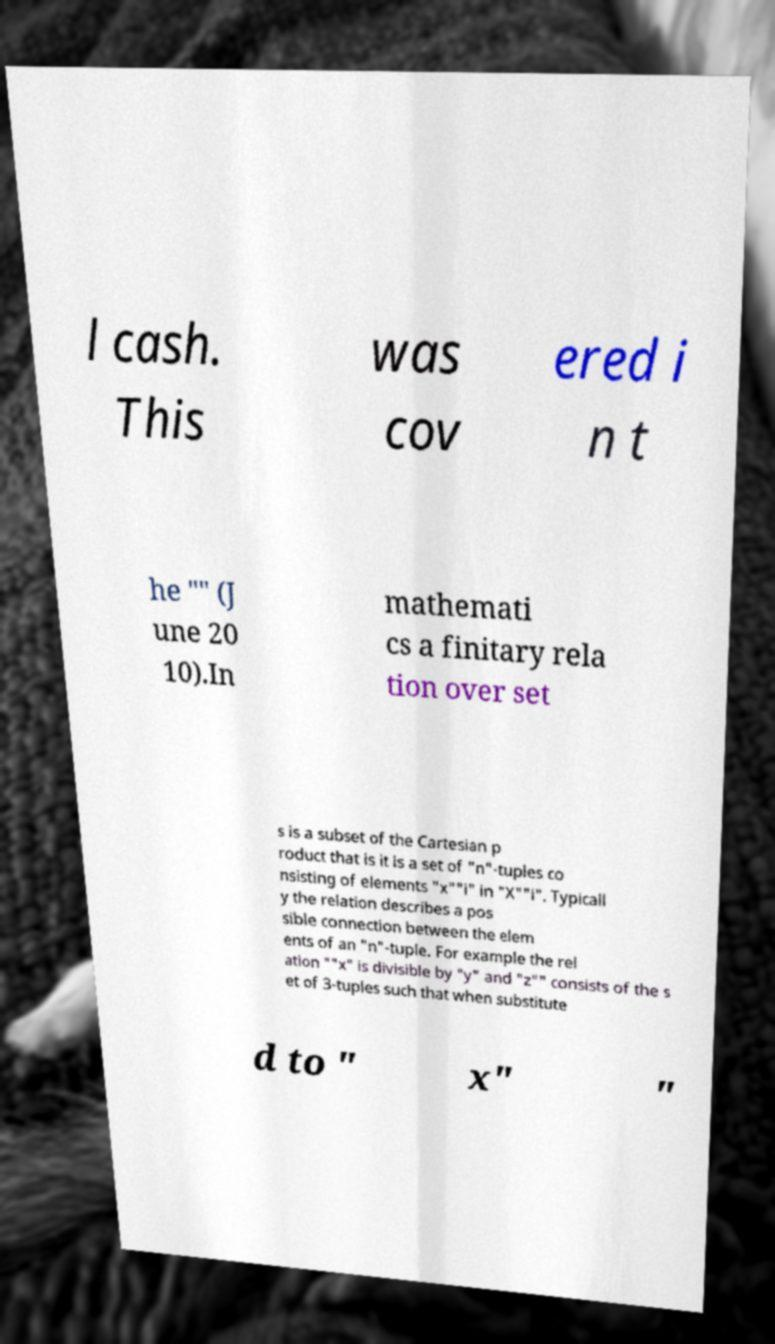Please identify and transcribe the text found in this image. l cash. This was cov ered i n t he "" (J une 20 10).In mathemati cs a finitary rela tion over set s is a subset of the Cartesian p roduct that is it is a set of "n"-tuples co nsisting of elements "x""i" in "X""i". Typicall y the relation describes a pos sible connection between the elem ents of an "n"-tuple. For example the rel ation ""x" is divisible by "y" and "z"" consists of the s et of 3-tuples such that when substitute d to " x" " 